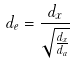<formula> <loc_0><loc_0><loc_500><loc_500>d _ { e } = \frac { d _ { x } } { \sqrt { \frac { d _ { x } } { d _ { a } } } }</formula> 